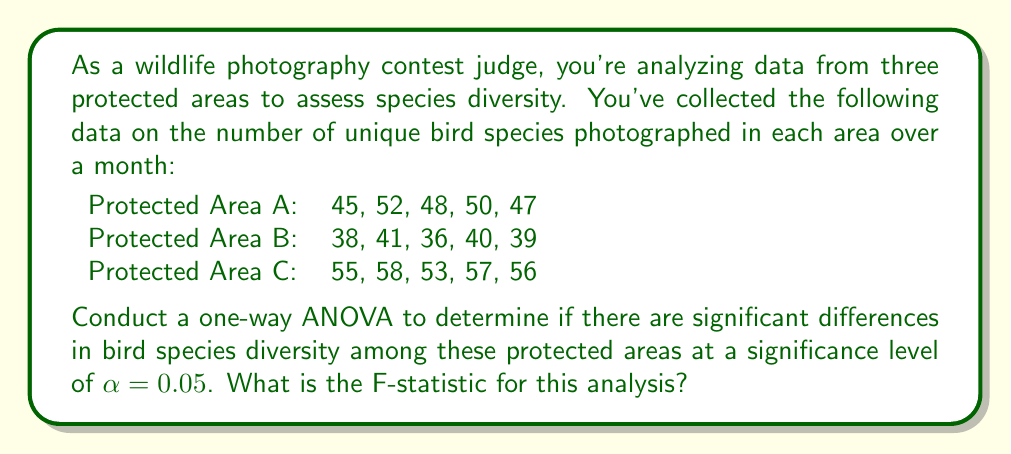Can you solve this math problem? To conduct a one-way ANOVA, we'll follow these steps:

1. Calculate the mean for each group and the overall mean:
   Area A mean: $\bar{x}_A = \frac{45 + 52 + 48 + 50 + 47}{5} = 48.4$
   Area B mean: $\bar{x}_B = \frac{38 + 41 + 36 + 40 + 39}{5} = 38.8$
   Area C mean: $\bar{x}_C = \frac{55 + 58 + 53 + 57 + 56}{5} = 55.8$
   Overall mean: $\bar{x} = \frac{48.4 + 38.8 + 55.8}{3} = 47.67$

2. Calculate the Sum of Squares Between groups (SSB):
   $$SSB = \sum_{i=1}^k n_i(\bar{x}_i - \bar{x})^2$$
   $$SSB = 5(48.4 - 47.67)^2 + 5(38.8 - 47.67)^2 + 5(55.8 - 47.67)^2 = 721.13$$

3. Calculate the Sum of Squares Within groups (SSW):
   $$SSW = \sum_{i=1}^k \sum_{j=1}^{n_i} (x_{ij} - \bar{x}_i)^2$$
   Area A: $(45-48.4)^2 + (52-48.4)^2 + (48-48.4)^2 + (50-48.4)^2 + (47-48.4)^2 = 30.8$
   Area B: $(38-38.8)^2 + (41-38.8)^2 + (36-38.8)^2 + (40-38.8)^2 + (39-38.8)^2 = 14.8$
   Area C: $(55-55.8)^2 + (58-55.8)^2 + (53-55.8)^2 + (57-55.8)^2 + (56-55.8)^2 = 14.8$
   $$SSW = 30.8 + 14.8 + 14.8 = 60.4$$

4. Calculate degrees of freedom:
   Between groups: $df_B = k - 1 = 3 - 1 = 2$
   Within groups: $df_W = N - k = 15 - 3 = 12$

5. Calculate Mean Square Between (MSB) and Mean Square Within (MSW):
   $$MSB = \frac{SSB}{df_B} = \frac{721.13}{2} = 360.565$$
   $$MSW = \frac{SSW}{df_W} = \frac{60.4}{12} = 5.033$$

6. Calculate the F-statistic:
   $$F = \frac{MSB}{MSW} = \frac{360.565}{5.033} = 71.64$$
Answer: The F-statistic for this one-way ANOVA is 71.64. 